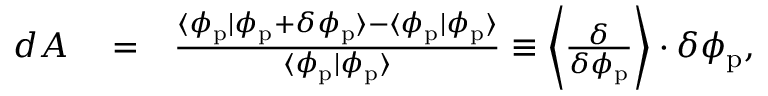<formula> <loc_0><loc_0><loc_500><loc_500>\begin{array} { r l r } { d A } & = } & { \frac { \langle \phi _ { p } | \phi _ { p } + \delta \phi _ { p } \rangle - \langle \phi _ { p } | \phi _ { p } \rangle } { \langle \phi _ { p } | \phi _ { p } \rangle } \equiv \left \langle \frac { \delta } { \delta \phi _ { p } } \right \rangle \cdot \delta \phi _ { p } , } \end{array}</formula> 